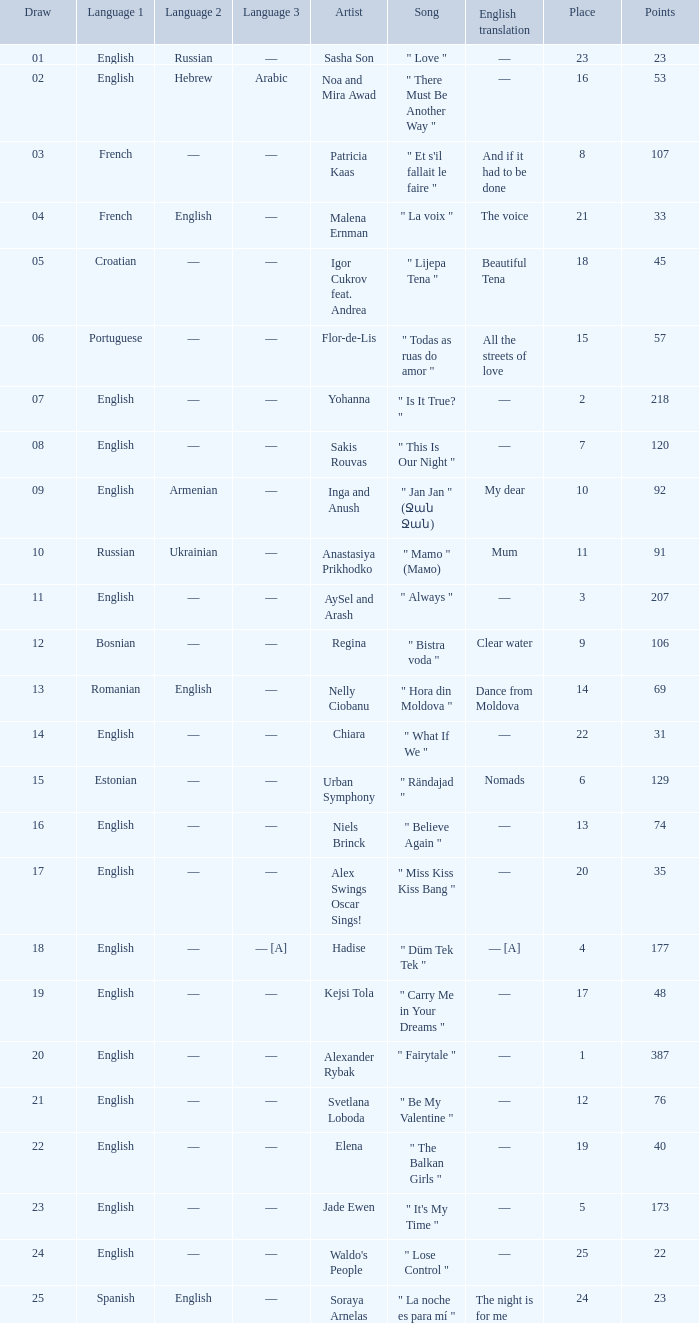What was the average place for the song that had 69 points and a draw smaller than 13? None. 